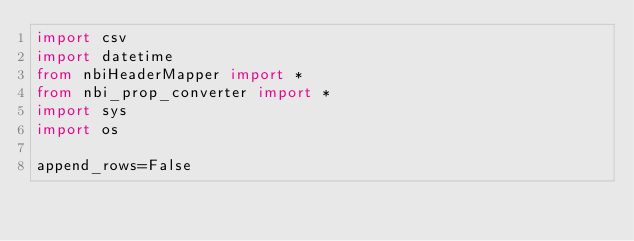Convert code to text. <code><loc_0><loc_0><loc_500><loc_500><_Python_>import csv
import datetime
from nbiHeaderMapper import *
from nbi_prop_converter import *
import sys
import os

append_rows=False</code> 